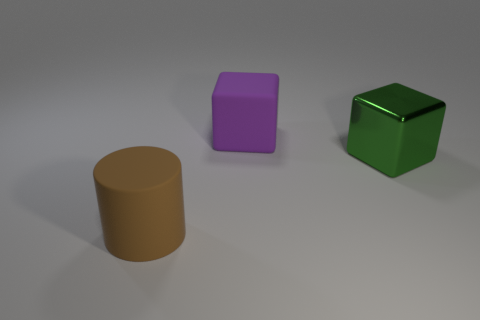What size is the purple cube that is made of the same material as the large brown object?
Provide a short and direct response. Large. Are there more brown shiny cylinders than purple matte cubes?
Offer a terse response. No. There is a green object that is the same size as the matte block; what material is it?
Provide a short and direct response. Metal. There is a thing that is behind the metallic cube; does it have the same size as the brown rubber object?
Offer a terse response. Yes. What number of cubes are either large purple things or big shiny things?
Offer a terse response. 2. What is the thing to the left of the purple thing made of?
Offer a very short reply. Rubber. Is the number of large green rubber cylinders less than the number of brown cylinders?
Provide a short and direct response. Yes. There is a thing that is both to the right of the brown cylinder and to the left of the large green cube; what is its size?
Ensure brevity in your answer.  Large. What number of other things are the same color as the cylinder?
Keep it short and to the point. 0. How many objects are yellow rubber spheres or cylinders?
Your answer should be compact. 1. 